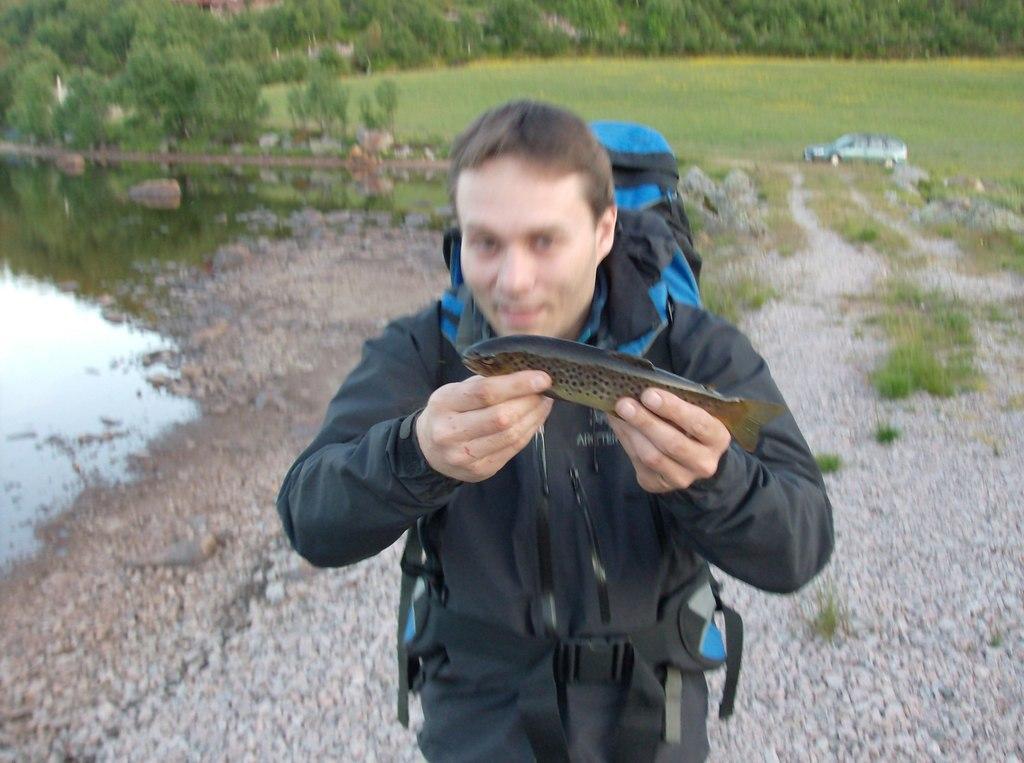Please provide a concise description of this image. In the background we can see the trees, grass, car. On the left side of the picture we can see the water. In this picture we can see a man wearing a backpack and he is holding a fish with his hands. On the ground we can see the stones. 